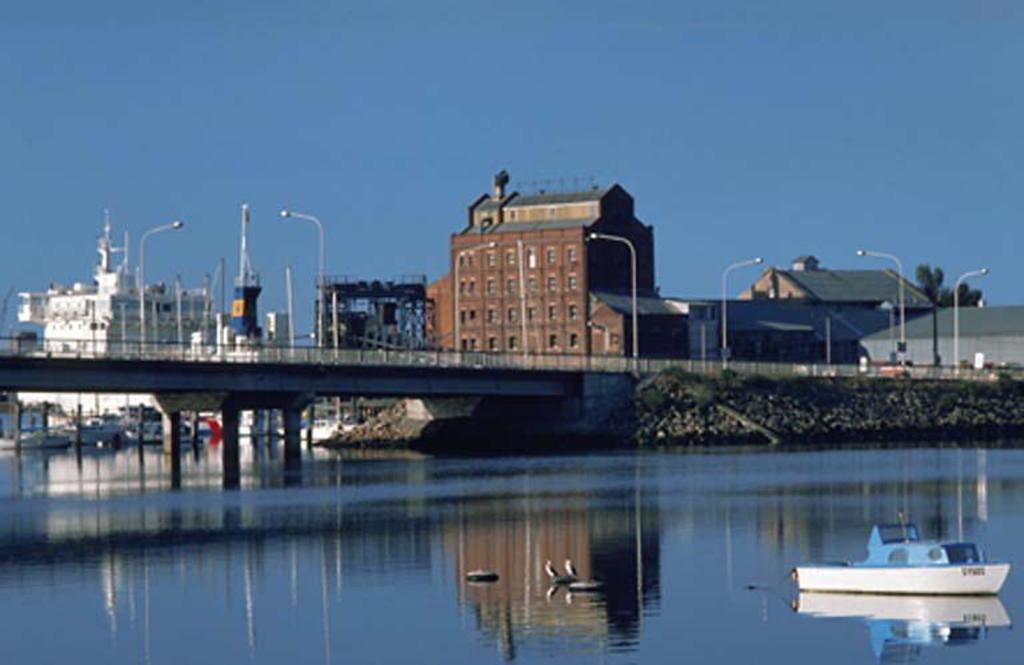Could you give a brief overview of what you see in this image? In this picture we can see a boat and birds on water, bridge, pillars, buildings, pole, trees and in the background we can see the sky. 